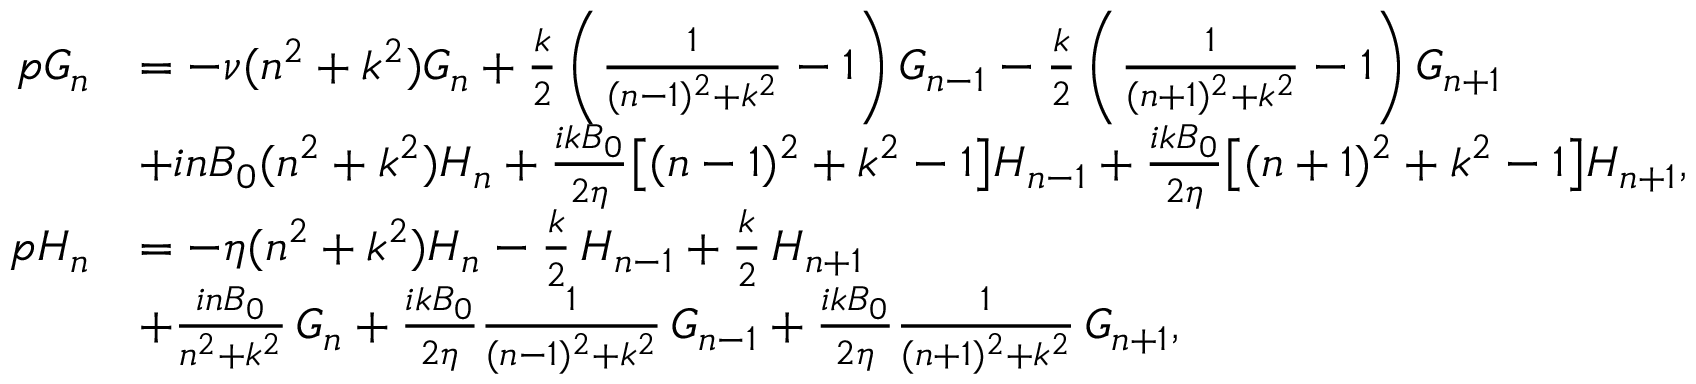<formula> <loc_0><loc_0><loc_500><loc_500>\begin{array} { r l } { p G _ { n } } & { = - \nu ( n ^ { 2 } + k ^ { 2 } ) G _ { n } + \frac { k } { 2 } \left ( \frac { 1 } { ( n - 1 ) ^ { 2 } + k ^ { 2 } } - 1 \right ) G _ { n - 1 } - \frac { k } { 2 } \left ( \frac { 1 } { ( n + 1 ) ^ { 2 } + k ^ { 2 } } - 1 \right ) G _ { n + 1 } } \\ & { + i n B _ { 0 } ( n ^ { 2 } + k ^ { 2 } ) H _ { n } + \frac { i k B _ { 0 } } { 2 \eta } \left [ ( n - 1 ) ^ { 2 } + k ^ { 2 } - 1 \right ] H _ { n - 1 } + \frac { i k B _ { 0 } } { 2 \eta } \left [ ( n + 1 ) ^ { 2 } + k ^ { 2 } - 1 \right ] H _ { n + 1 } , } \\ { p H _ { n } } & { = - \eta ( n ^ { 2 } + k ^ { 2 } ) H _ { n } - \frac { k } { 2 } \, H _ { n - 1 } + \frac { k } { 2 } \, H _ { n + 1 } } \\ & { + \frac { i n B _ { 0 } } { n ^ { 2 } + k ^ { 2 } } \, G _ { n } + \frac { i k B _ { 0 } } { 2 \eta } \frac { 1 } { ( n - 1 ) ^ { 2 } + k ^ { 2 } } \, G _ { n - 1 } + \frac { i k B _ { 0 } } { 2 \eta } \frac { 1 } { ( n + 1 ) ^ { 2 } + k ^ { 2 } } \, G _ { n + 1 } , } \end{array}</formula> 